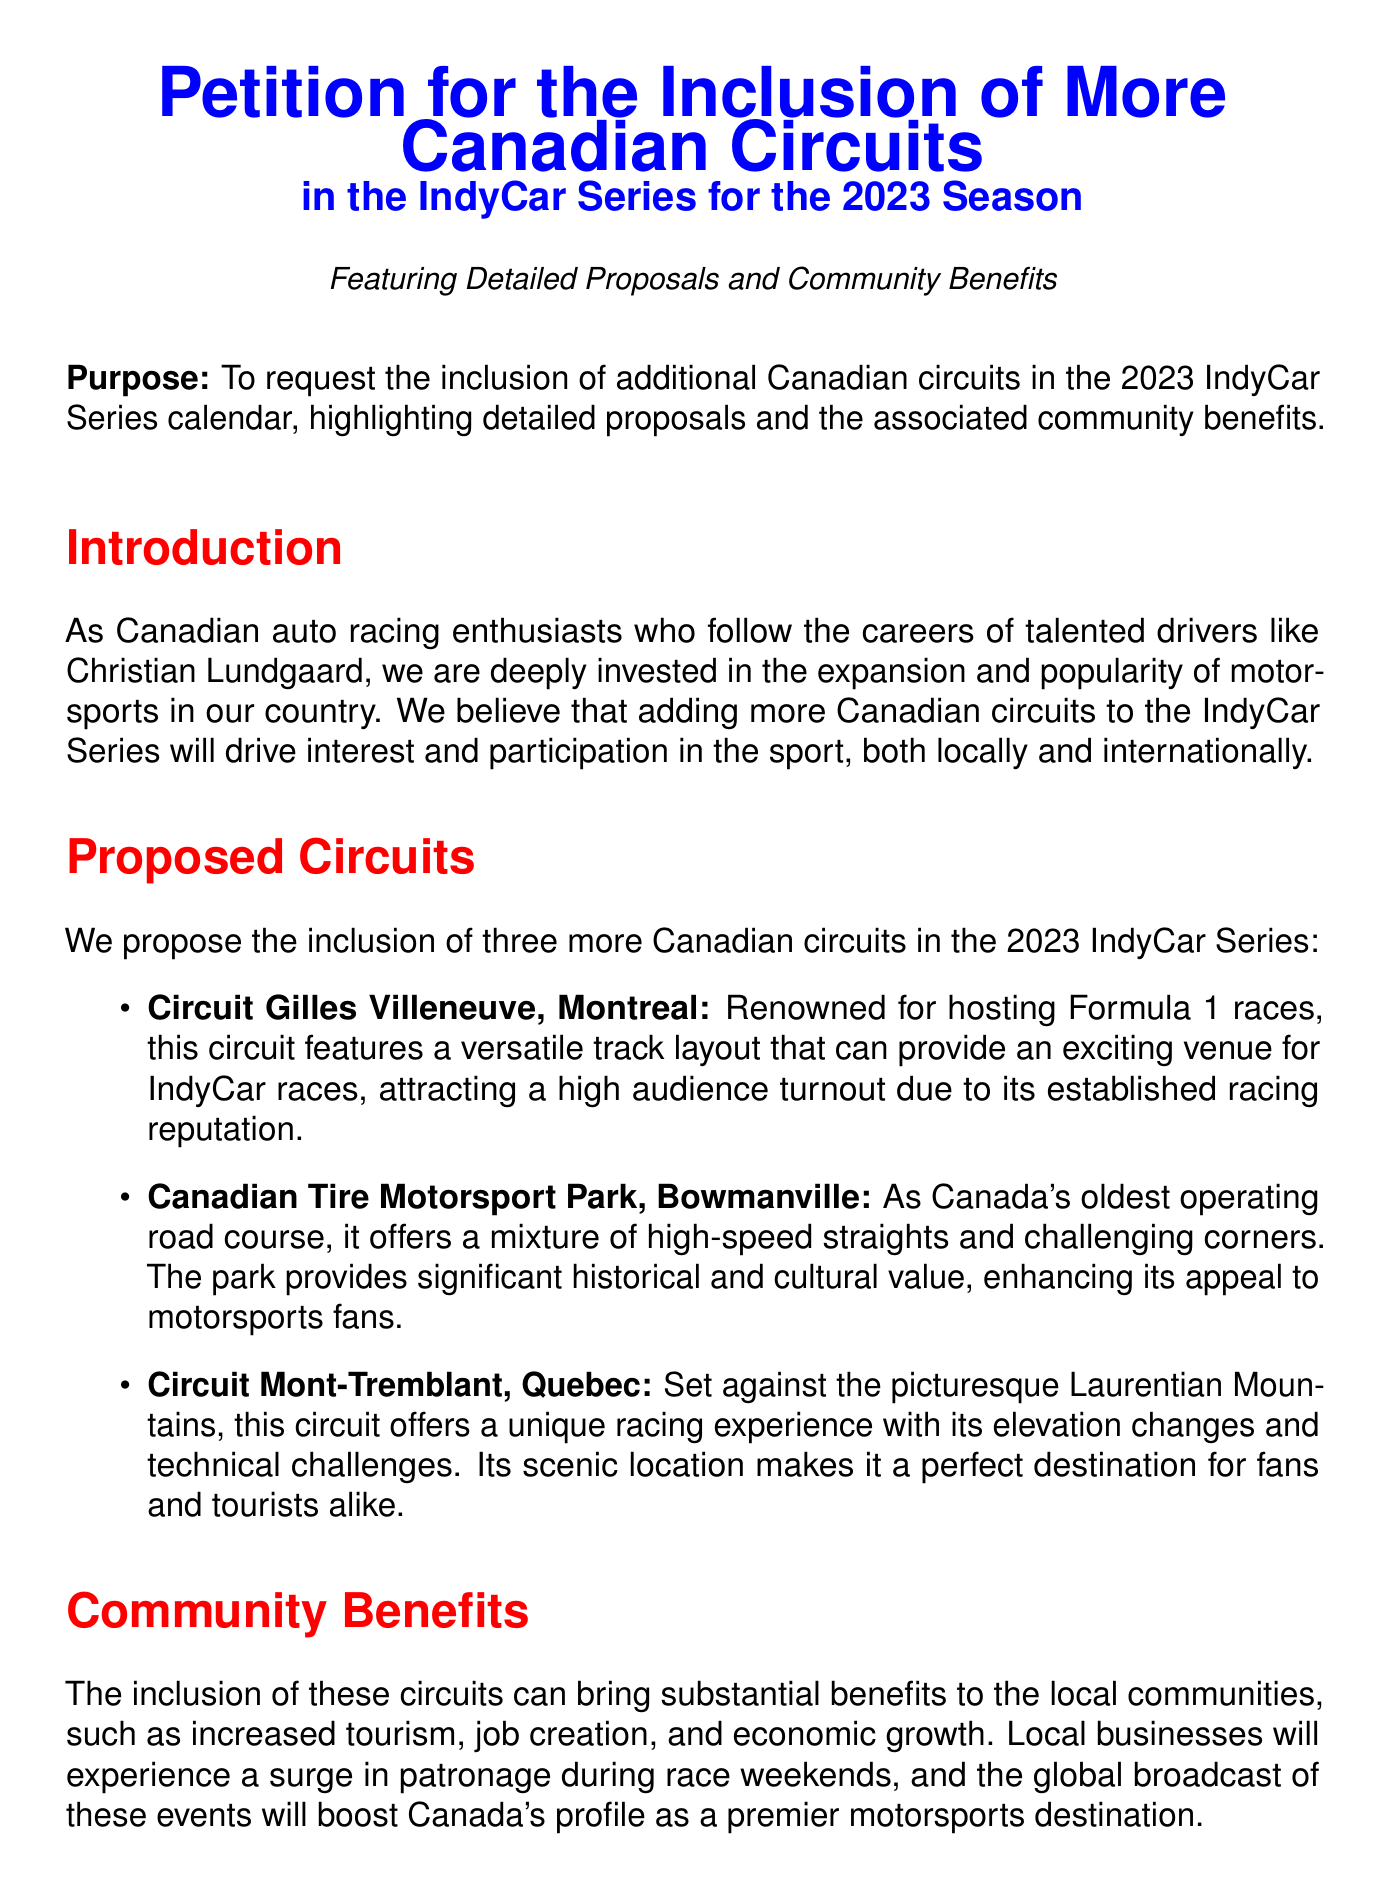What is the purpose of the petition? The purpose of the petition is to request the inclusion of additional Canadian circuits in the 2023 IndyCar Series calendar, highlighting detailed proposals and the associated community benefits.
Answer: Request the inclusion of additional Canadian circuits What are the three proposed circuits? The document lists Circuit Gilles Villeneuve, Canadian Tire Motorsport Park, and Circuit Mont-Tremblant as the proposed circuits for inclusion.
Answer: Circuit Gilles Villeneuve, Canadian Tire Motorsport Park, Circuit Mont-Tremblant What significant circuit is located in Montreal? The significant circuit mentioned in Montreal is known for hosting Formula 1 races and is called Circuit Gilles Villeneuve.
Answer: Circuit Gilles Villeneuve How many Canadian circuits are proposed? The document proposes three additional Canadian circuits for the 2023 IndyCar Series.
Answer: Three What type of growth is expected from including more circuits? The document indicates that the inclusion of additional circuits is expected to bring economic growth to local communities.
Answer: Economic growth What community benefits are highlighted? The document highlights increased tourism, job creation, and economic growth as community benefits of adding more circuits.
Answer: Increased tourism, job creation, economic growth What is the call to action in the petition? The call to action urges the IndyCar Series organizers to consider the proposal for including more Canadian circuits.
Answer: Consider our proposal Which driver is mentioned as an influence in the petition? The document mentions Christian Lundgaard, highlighting the interest in talented drivers in the petition.
Answer: Christian Lundgaard 